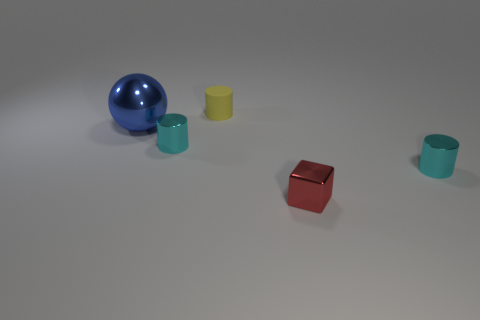Subtract all tiny cyan cylinders. How many cylinders are left? 1 Subtract all yellow cylinders. How many cylinders are left? 2 Subtract 1 blocks. How many blocks are left? 0 Subtract all brown cubes. How many cyan cylinders are left? 2 Add 5 small blocks. How many objects exist? 10 Subtract all cylinders. How many objects are left? 2 Subtract all tiny purple shiny cylinders. Subtract all cubes. How many objects are left? 4 Add 5 blue balls. How many blue balls are left? 6 Add 3 blue spheres. How many blue spheres exist? 4 Subtract 0 yellow blocks. How many objects are left? 5 